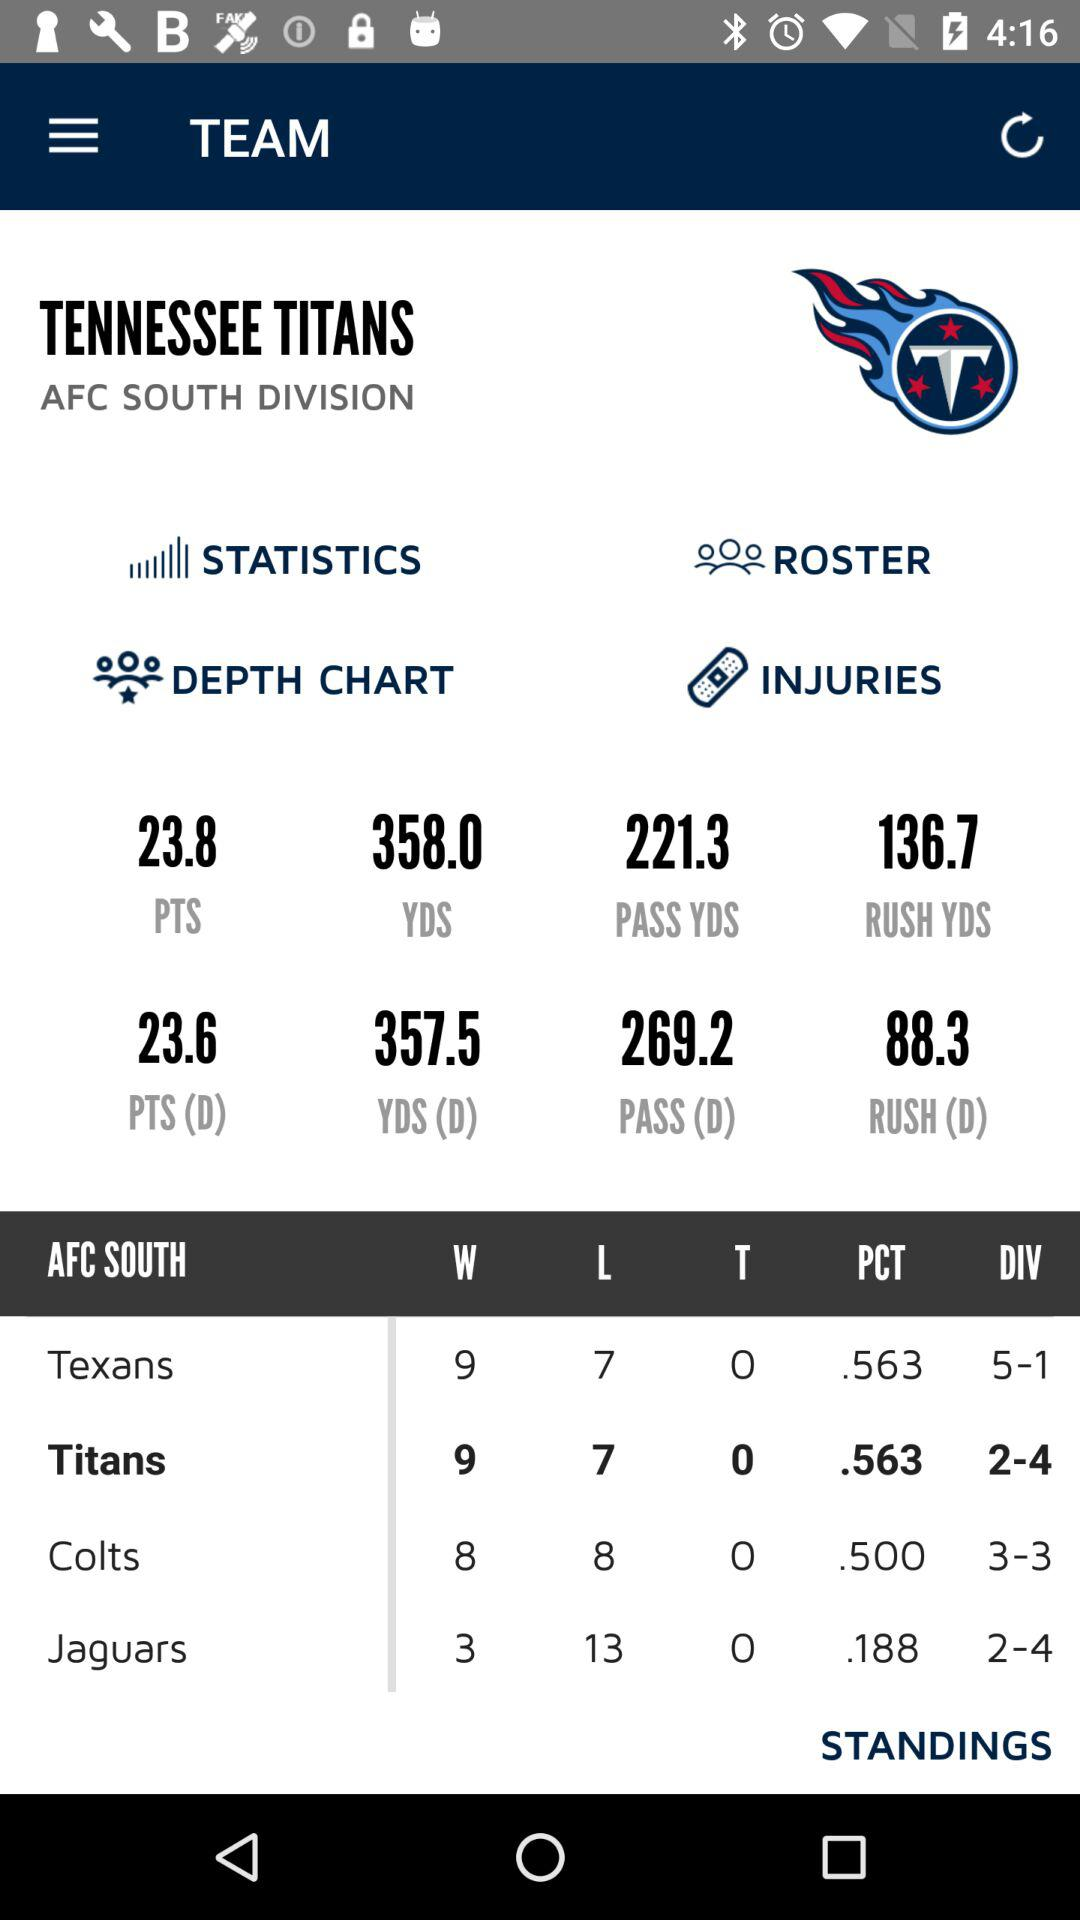Which team has a better overall record, the Titans or the Jaguars?
Answer the question using a single word or phrase. Titans 